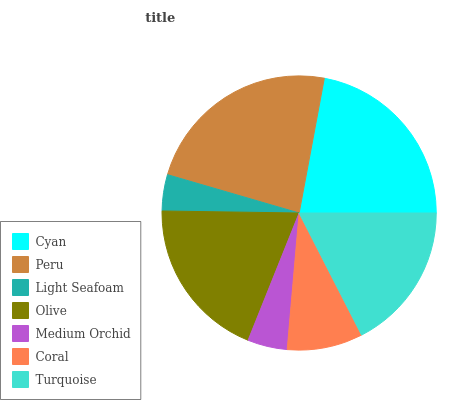Is Light Seafoam the minimum?
Answer yes or no. Yes. Is Peru the maximum?
Answer yes or no. Yes. Is Peru the minimum?
Answer yes or no. No. Is Light Seafoam the maximum?
Answer yes or no. No. Is Peru greater than Light Seafoam?
Answer yes or no. Yes. Is Light Seafoam less than Peru?
Answer yes or no. Yes. Is Light Seafoam greater than Peru?
Answer yes or no. No. Is Peru less than Light Seafoam?
Answer yes or no. No. Is Turquoise the high median?
Answer yes or no. Yes. Is Turquoise the low median?
Answer yes or no. Yes. Is Olive the high median?
Answer yes or no. No. Is Light Seafoam the low median?
Answer yes or no. No. 